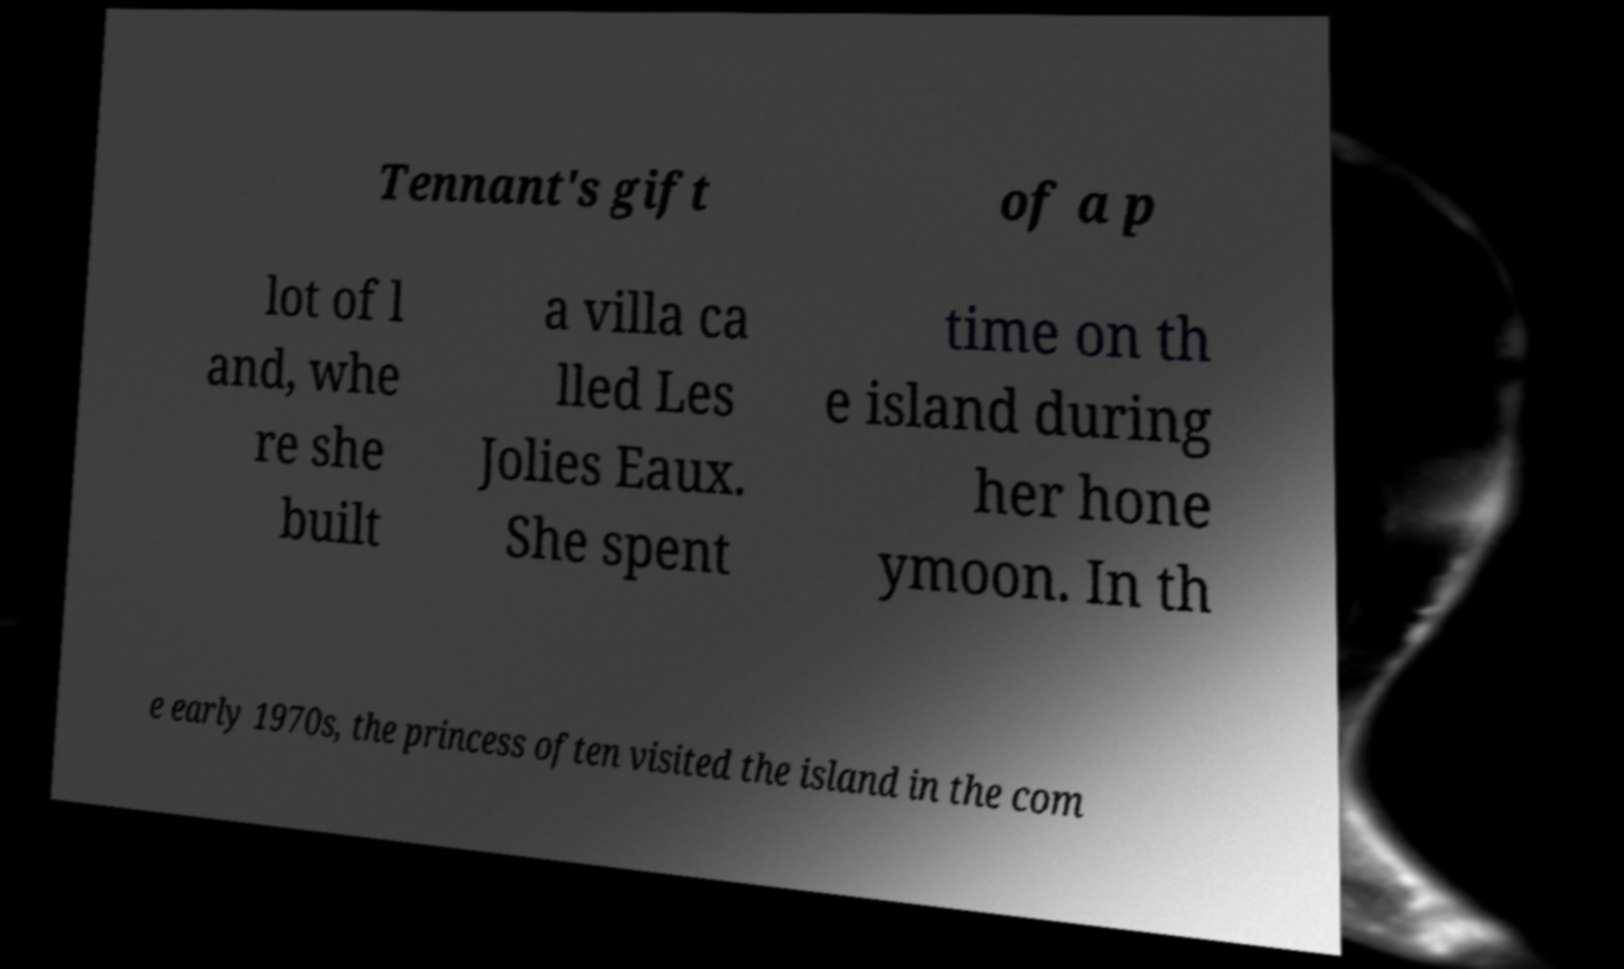For documentation purposes, I need the text within this image transcribed. Could you provide that? Tennant's gift of a p lot of l and, whe re she built a villa ca lled Les Jolies Eaux. She spent time on th e island during her hone ymoon. In th e early 1970s, the princess often visited the island in the com 